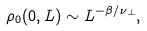Convert formula to latex. <formula><loc_0><loc_0><loc_500><loc_500>\rho _ { 0 } ( 0 , L ) \sim L ^ { - \beta / \nu _ { \perp } } ,</formula> 